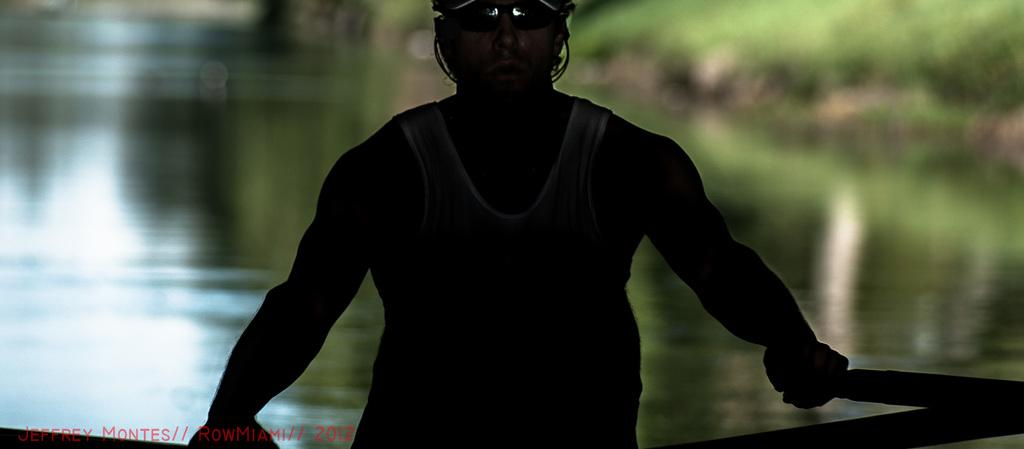What is the main subject of the image? There is a person in the middle of the image. What is the person holding in the image? The person is holding pedals. What can be seen behind the person in the image? There is water visible behind the person. How would you describe the background of the image? The background of the image is blurred. What type of taste can be experienced from the person's clothing in the image? There is no information about the taste of the person's clothing in the image. 